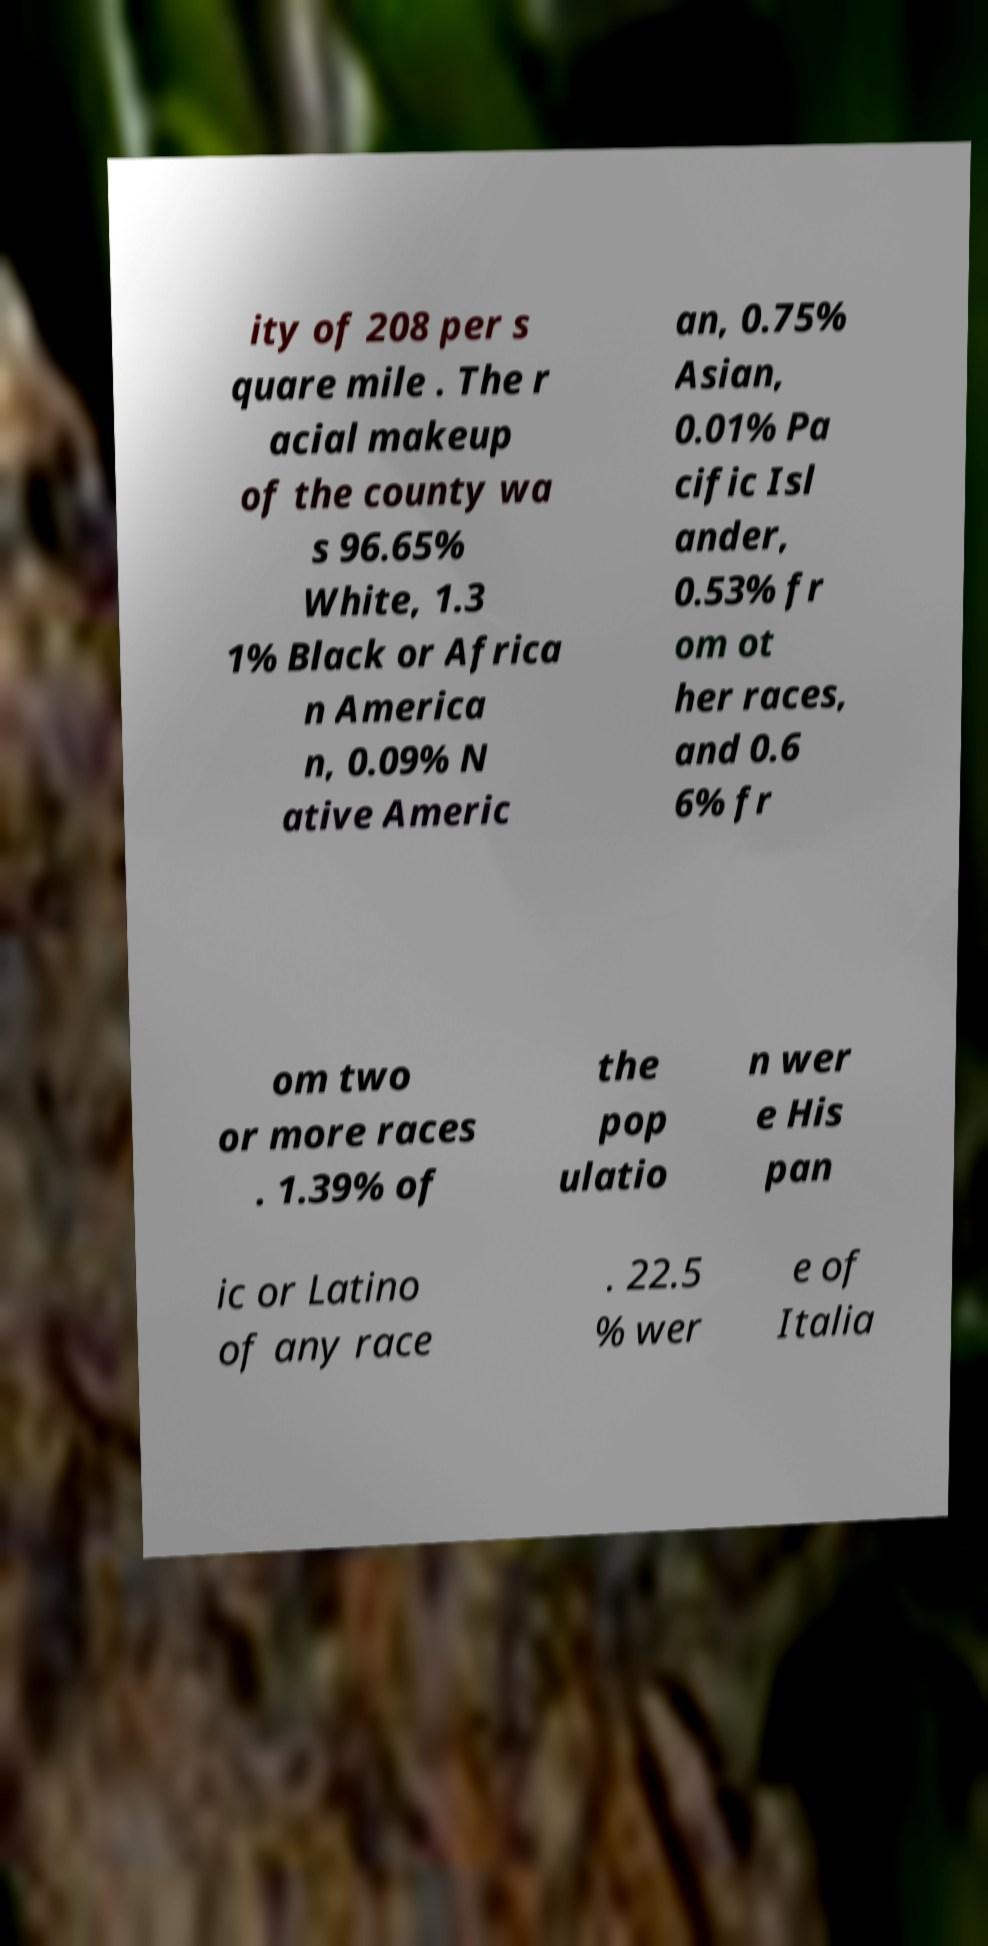What messages or text are displayed in this image? I need them in a readable, typed format. ity of 208 per s quare mile . The r acial makeup of the county wa s 96.65% White, 1.3 1% Black or Africa n America n, 0.09% N ative Americ an, 0.75% Asian, 0.01% Pa cific Isl ander, 0.53% fr om ot her races, and 0.6 6% fr om two or more races . 1.39% of the pop ulatio n wer e His pan ic or Latino of any race . 22.5 % wer e of Italia 